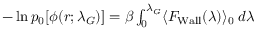Convert formula to latex. <formula><loc_0><loc_0><loc_500><loc_500>\begin{array} { r } { - \ln p _ { 0 } [ \phi ( r ; \lambda _ { G } ) ] = \beta \int _ { 0 } ^ { \lambda _ { G } } \langle F _ { W a l l } ( \lambda ) \rangle _ { 0 } \, d \lambda } \end{array}</formula> 